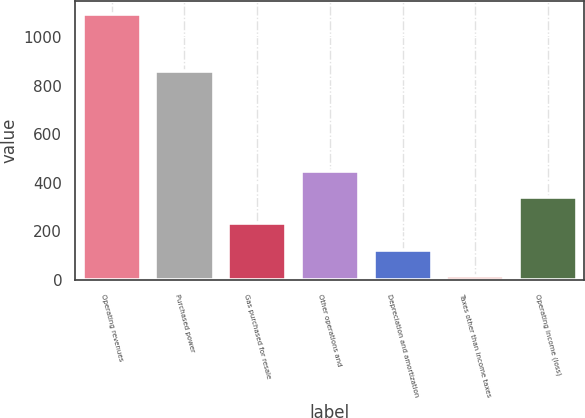<chart> <loc_0><loc_0><loc_500><loc_500><bar_chart><fcel>Operating revenues<fcel>Purchased power<fcel>Gas purchased for resale<fcel>Other operations and<fcel>Depreciation and amortization<fcel>Taxes other than income taxes<fcel>Operating income (loss)<nl><fcel>1096<fcel>861<fcel>232.8<fcel>448.6<fcel>124.9<fcel>17<fcel>340.7<nl></chart> 